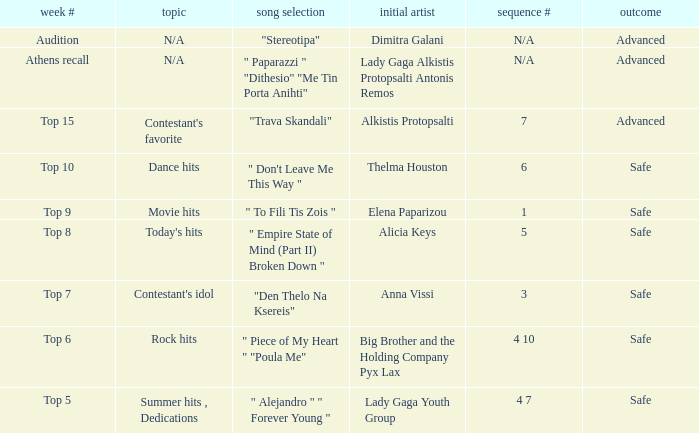What are all the order #s from the week "top 6"? 4 10. Would you mind parsing the complete table? {'header': ['week #', 'topic', 'song selection', 'initial artist', 'sequence #', 'outcome'], 'rows': [['Audition', 'N/A', '"Stereotipa"', 'Dimitra Galani', 'N/A', 'Advanced'], ['Athens recall', 'N/A', '" Paparazzi " "Dithesio" "Me Tin Porta Anihti"', 'Lady Gaga Alkistis Protopsalti Antonis Remos', 'N/A', 'Advanced'], ['Top 15', "Contestant's favorite", '"Trava Skandali"', 'Alkistis Protopsalti', '7', 'Advanced'], ['Top 10', 'Dance hits', '" Don\'t Leave Me This Way "', 'Thelma Houston', '6', 'Safe'], ['Top 9', 'Movie hits', '" To Fili Tis Zois "', 'Elena Paparizou', '1', 'Safe'], ['Top 8', "Today's hits", '" Empire State of Mind (Part II) Broken Down "', 'Alicia Keys', '5', 'Safe'], ['Top 7', "Contestant's idol", '"Den Thelo Na Ksereis"', 'Anna Vissi', '3', 'Safe'], ['Top 6', 'Rock hits', '" Piece of My Heart " "Poula Me"', 'Big Brother and the Holding Company Pyx Lax', '4 10', 'Safe'], ['Top 5', 'Summer hits , Dedications', '" Alejandro " " Forever Young "', 'Lady Gaga Youth Group', '4 7', 'Safe']]} 